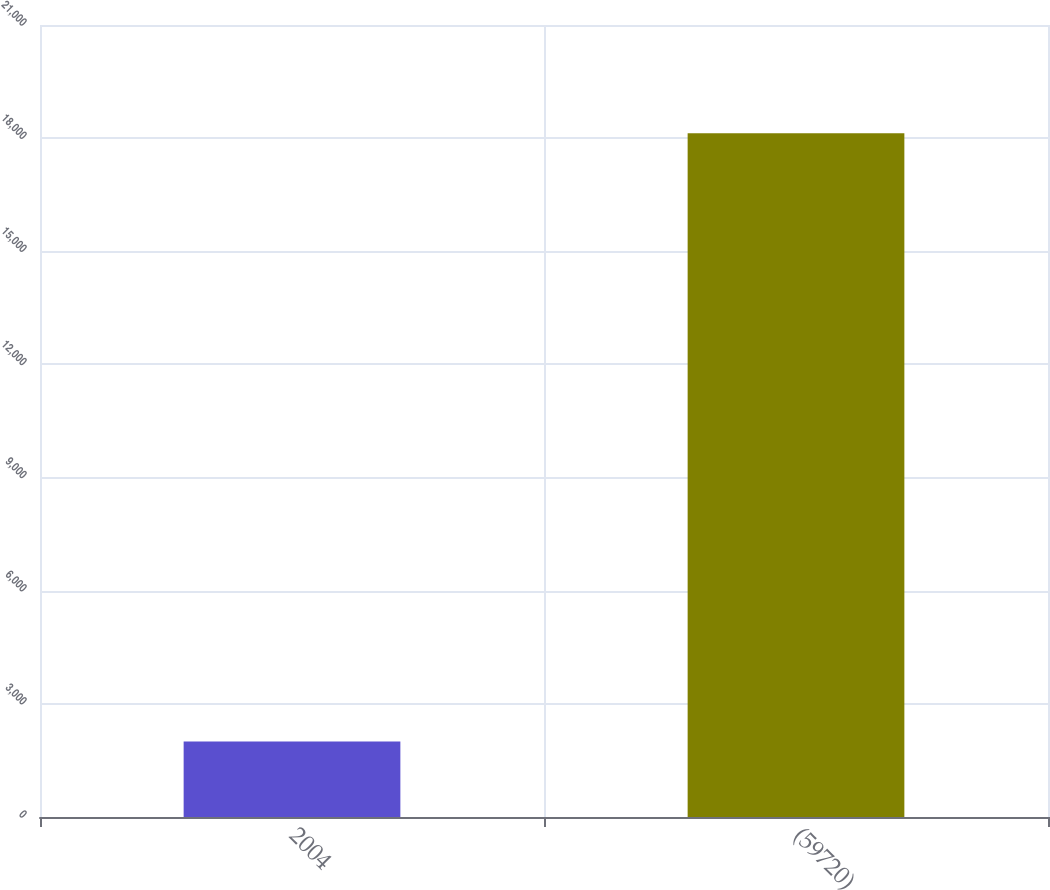<chart> <loc_0><loc_0><loc_500><loc_500><bar_chart><fcel>2004<fcel>(59720)<nl><fcel>2002<fcel>18131<nl></chart> 